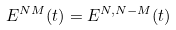<formula> <loc_0><loc_0><loc_500><loc_500>E ^ { N M } ( t ) = E ^ { N , N - M } ( t )</formula> 